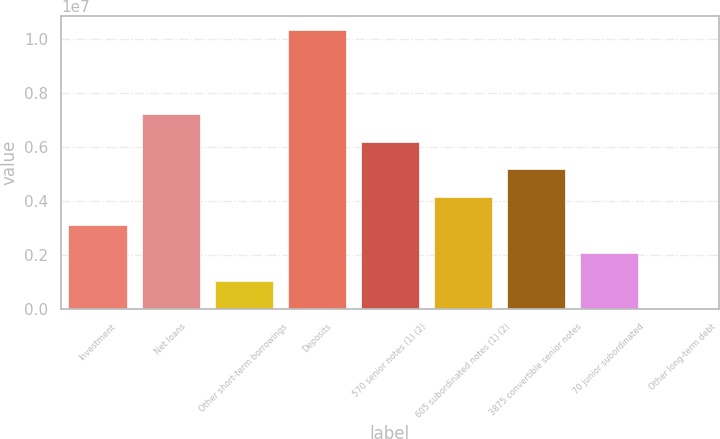Convert chart. <chart><loc_0><loc_0><loc_500><loc_500><bar_chart><fcel>Investment<fcel>Net loans<fcel>Other short-term borrowings<fcel>Deposits<fcel>570 senior notes (1) (2)<fcel>605 subordinated notes (1) (2)<fcel>3875 convertible senior notes<fcel>70 junior subordinated<fcel>Other long-term debt<nl><fcel>3.10455e+06<fcel>7.23417e+06<fcel>1.03974e+06<fcel>1.03314e+07<fcel>6.20176e+06<fcel>4.13696e+06<fcel>5.16936e+06<fcel>2.07215e+06<fcel>7339<nl></chart> 